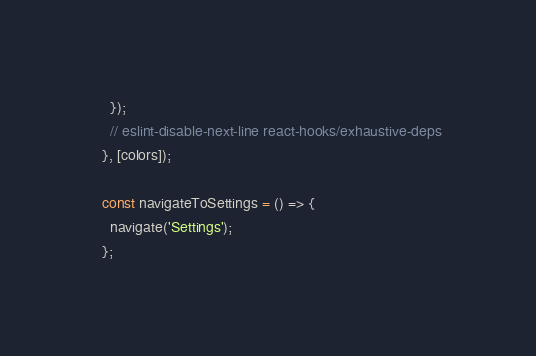<code> <loc_0><loc_0><loc_500><loc_500><_JavaScript_>    });
    // eslint-disable-next-line react-hooks/exhaustive-deps
  }, [colors]);

  const navigateToSettings = () => {
    navigate('Settings');
  };
</code> 